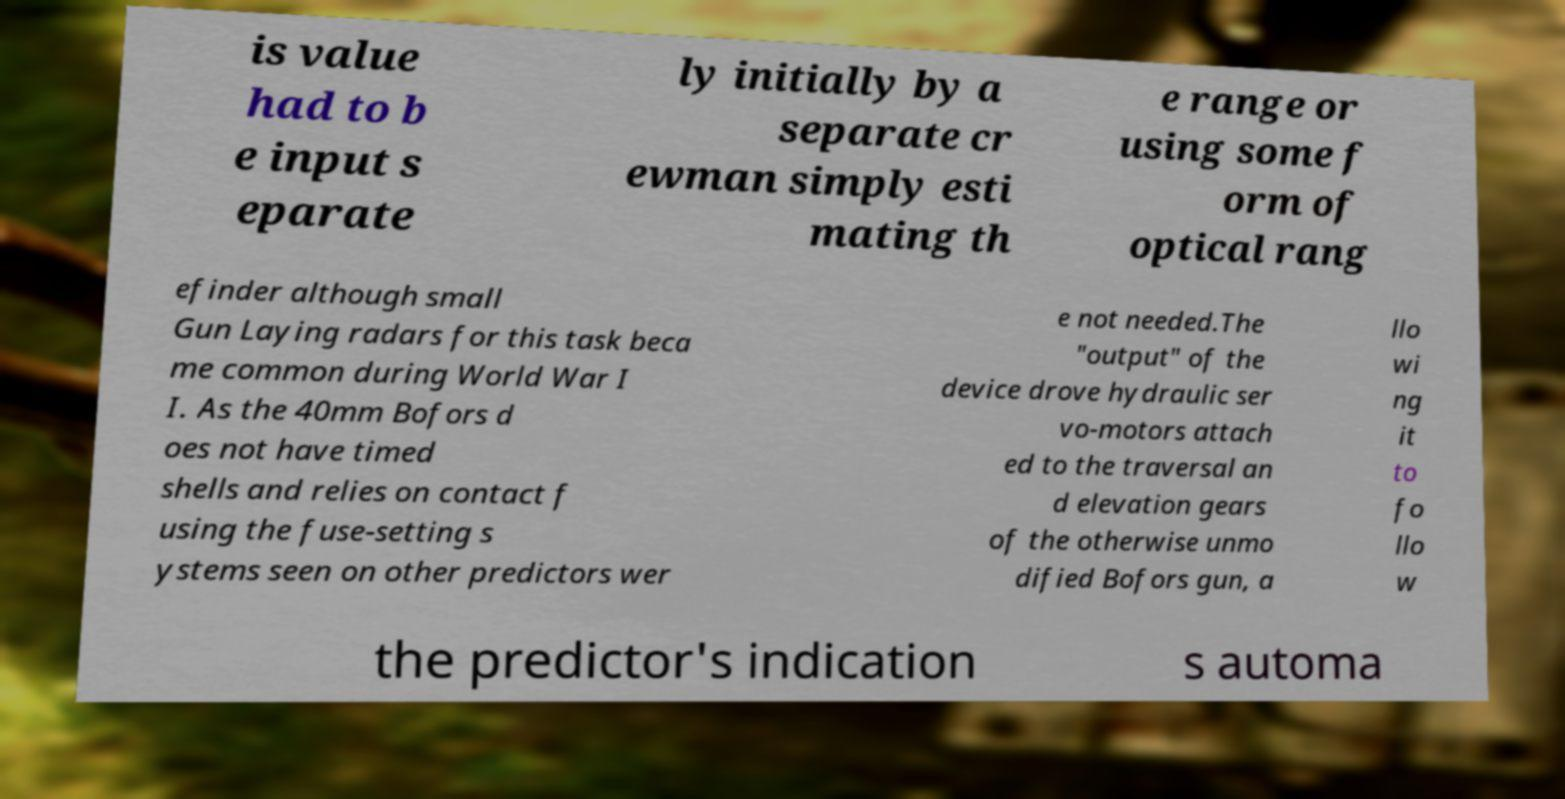There's text embedded in this image that I need extracted. Can you transcribe it verbatim? is value had to b e input s eparate ly initially by a separate cr ewman simply esti mating th e range or using some f orm of optical rang efinder although small Gun Laying radars for this task beca me common during World War I I. As the 40mm Bofors d oes not have timed shells and relies on contact f using the fuse-setting s ystems seen on other predictors wer e not needed.The "output" of the device drove hydraulic ser vo-motors attach ed to the traversal an d elevation gears of the otherwise unmo dified Bofors gun, a llo wi ng it to fo llo w the predictor's indication s automa 